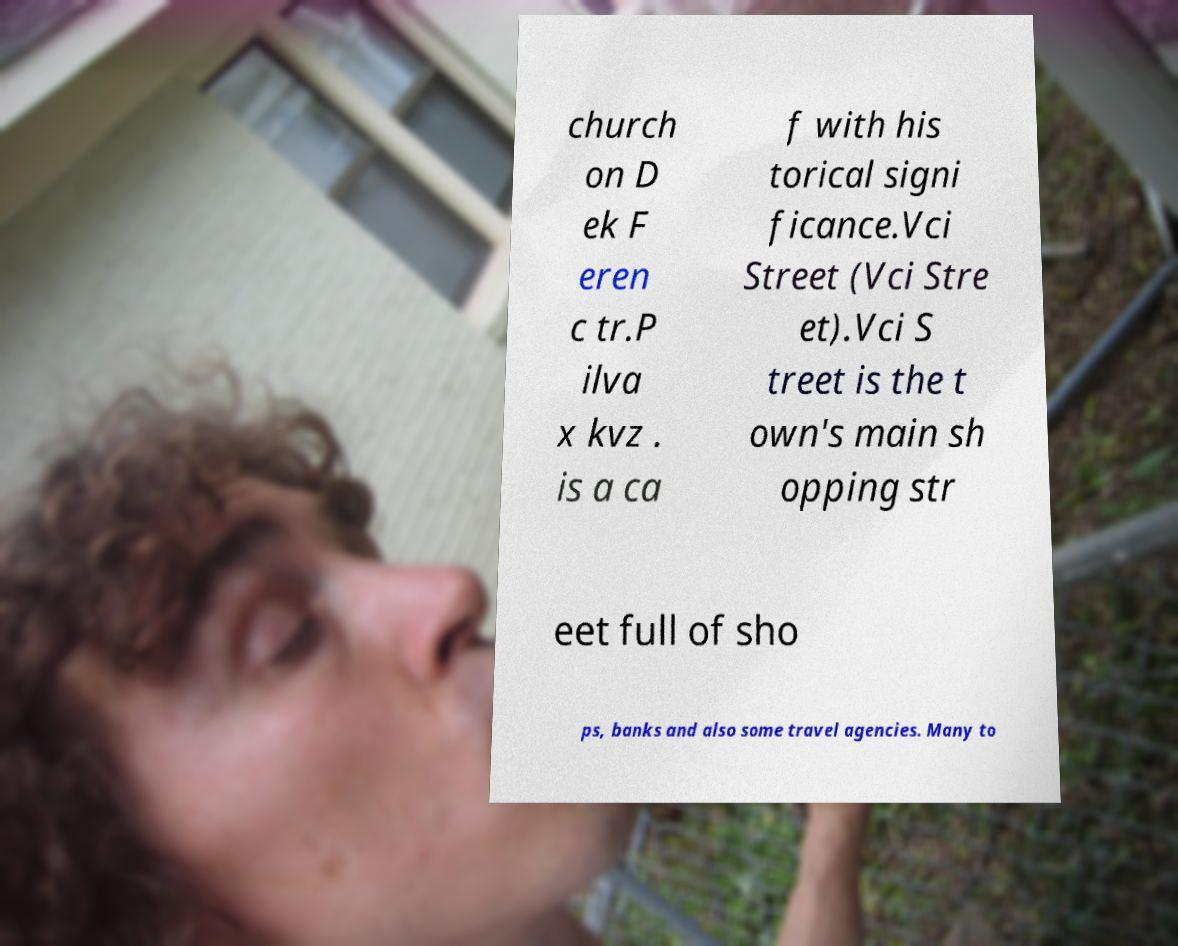Please identify and transcribe the text found in this image. church on D ek F eren c tr.P ilva x kvz . is a ca f with his torical signi ficance.Vci Street (Vci Stre et).Vci S treet is the t own's main sh opping str eet full of sho ps, banks and also some travel agencies. Many to 